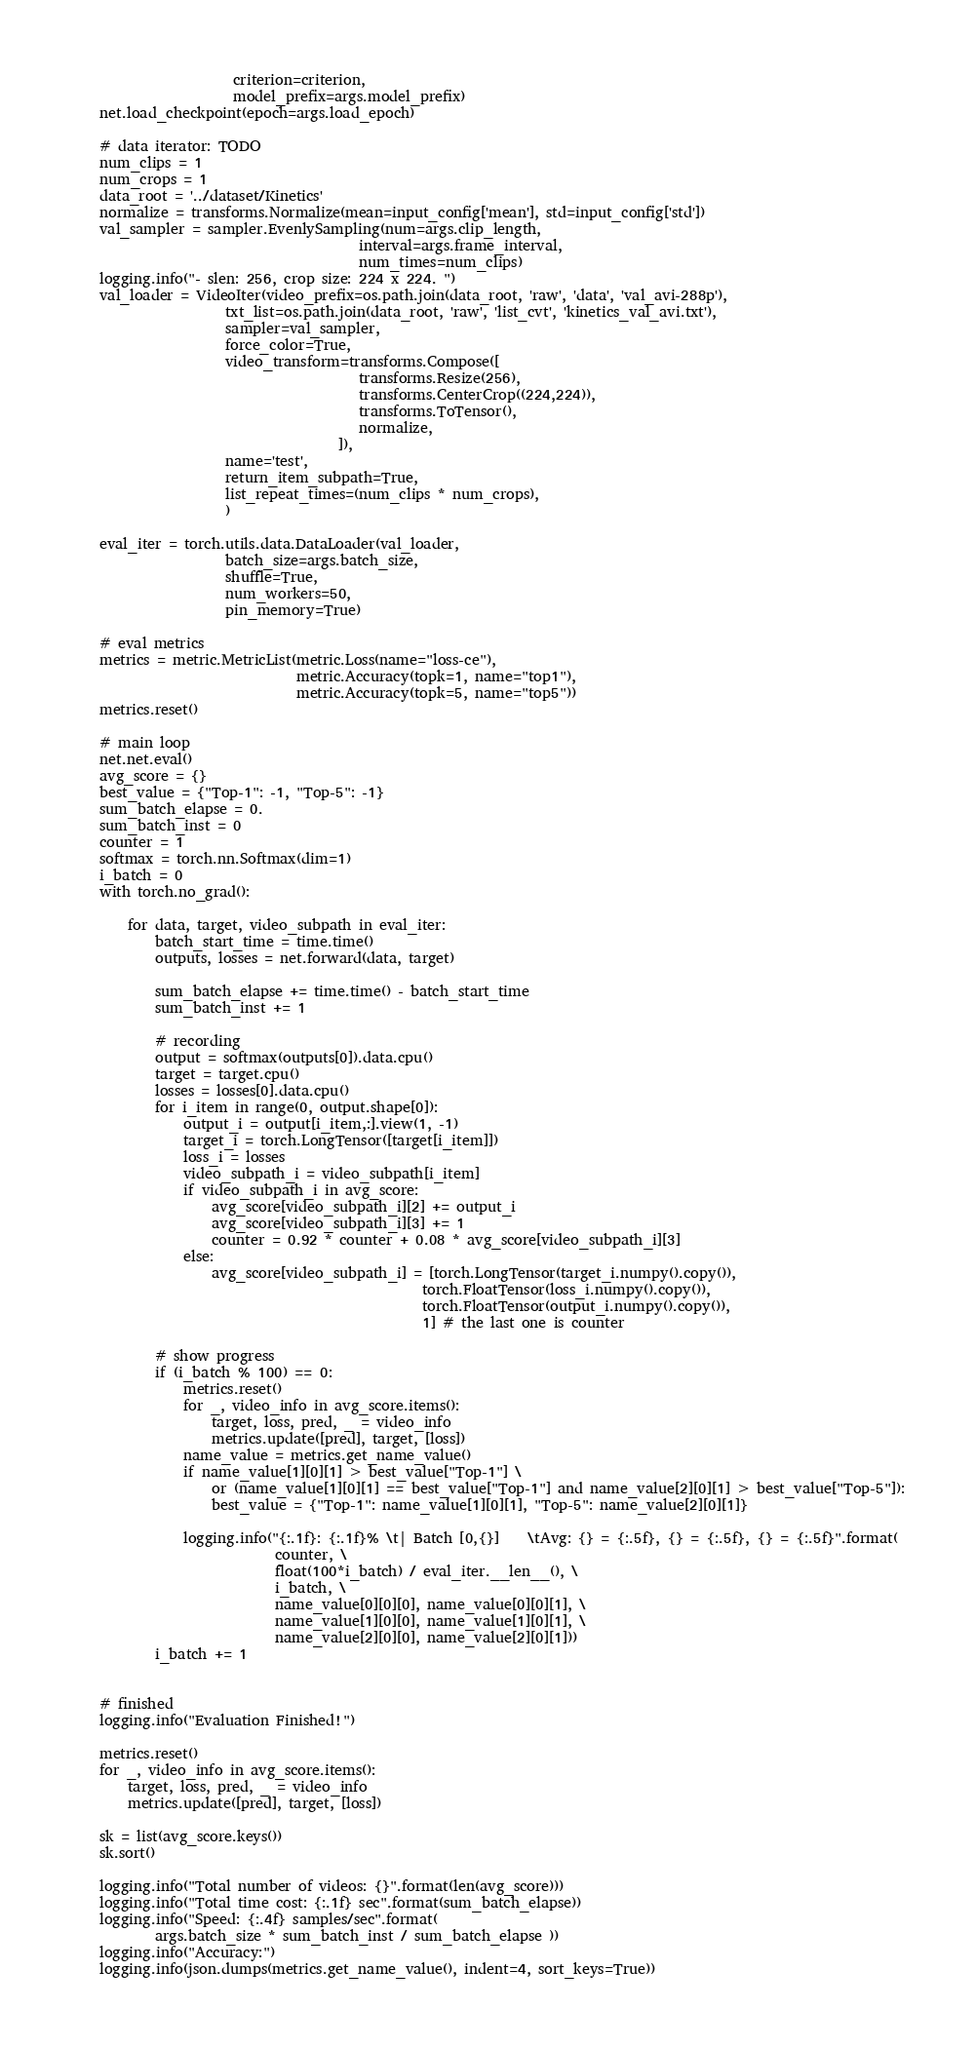Convert code to text. <code><loc_0><loc_0><loc_500><loc_500><_Python_>                       criterion=criterion,
                       model_prefix=args.model_prefix)
    net.load_checkpoint(epoch=args.load_epoch)

    # data iterator: TODO
    num_clips = 1
    num_crops = 1
    data_root = '../dataset/Kinetics'
    normalize = transforms.Normalize(mean=input_config['mean'], std=input_config['std'])
    val_sampler = sampler.EvenlySampling(num=args.clip_length,
                                         interval=args.frame_interval,
                                         num_times=num_clips)
    logging.info("- slen: 256, crop size: 224 x 224. ")
    val_loader = VideoIter(video_prefix=os.path.join(data_root, 'raw', 'data', 'val_avi-288p'),
                      txt_list=os.path.join(data_root, 'raw', 'list_cvt', 'kinetics_val_avi.txt'),
                      sampler=val_sampler,
                      force_color=True,
                      video_transform=transforms.Compose([
                                         transforms.Resize(256),
                                         transforms.CenterCrop((224,224)),
                                         transforms.ToTensor(),
                                         normalize,
                                      ]),
                      name='test',
                      return_item_subpath=True,
                      list_repeat_times=(num_clips * num_crops),
                      )

    eval_iter = torch.utils.data.DataLoader(val_loader,
                      batch_size=args.batch_size,
                      shuffle=True,
                      num_workers=50,
                      pin_memory=True)

    # eval metrics
    metrics = metric.MetricList(metric.Loss(name="loss-ce"),
                                metric.Accuracy(topk=1, name="top1"),
                                metric.Accuracy(topk=5, name="top5"))
    metrics.reset()

    # main loop
    net.net.eval()
    avg_score = {}
    best_value = {"Top-1": -1, "Top-5": -1}
    sum_batch_elapse = 0.
    sum_batch_inst = 0
    counter = 1
    softmax = torch.nn.Softmax(dim=1)
    i_batch = 0
    with torch.no_grad():

        for data, target, video_subpath in eval_iter:
            batch_start_time = time.time()
            outputs, losses = net.forward(data, target)

            sum_batch_elapse += time.time() - batch_start_time
            sum_batch_inst += 1

            # recording
            output = softmax(outputs[0]).data.cpu()
            target = target.cpu()
            losses = losses[0].data.cpu()
            for i_item in range(0, output.shape[0]):
                output_i = output[i_item,:].view(1, -1)
                target_i = torch.LongTensor([target[i_item]])
                loss_i = losses
                video_subpath_i = video_subpath[i_item]
                if video_subpath_i in avg_score:
                    avg_score[video_subpath_i][2] += output_i
                    avg_score[video_subpath_i][3] += 1
                    counter = 0.92 * counter + 0.08 * avg_score[video_subpath_i][3]
                else:
                    avg_score[video_subpath_i] = [torch.LongTensor(target_i.numpy().copy()),
                                                  torch.FloatTensor(loss_i.numpy().copy()),
                                                  torch.FloatTensor(output_i.numpy().copy()),
                                                  1] # the last one is counter

            # show progress
            if (i_batch % 100) == 0:
                metrics.reset()
                for _, video_info in avg_score.items():
                    target, loss, pred, _ = video_info
                    metrics.update([pred], target, [loss])
                name_value = metrics.get_name_value()
                if name_value[1][0][1] > best_value["Top-1"] \
                    or (name_value[1][0][1] == best_value["Top-1"] and name_value[2][0][1] > best_value["Top-5"]):
                    best_value = {"Top-1": name_value[1][0][1], "Top-5": name_value[2][0][1]}

                logging.info("{:.1f}: {:.1f}% \t| Batch [0,{}]    \tAvg: {} = {:.5f}, {} = {:.5f}, {} = {:.5f}".format(
                             counter, \
                             float(100*i_batch) / eval_iter.__len__(), \
                             i_batch, \
                             name_value[0][0][0], name_value[0][0][1], \
                             name_value[1][0][0], name_value[1][0][1], \
                             name_value[2][0][0], name_value[2][0][1]))
            i_batch += 1


    # finished
    logging.info("Evaluation Finished!")

    metrics.reset()
    for _, video_info in avg_score.items():
        target, loss, pred, _ = video_info
        metrics.update([pred], target, [loss])

    sk = list(avg_score.keys())
    sk.sort()

    logging.info("Total number of videos: {}".format(len(avg_score)))
    logging.info("Total time cost: {:.1f} sec".format(sum_batch_elapse))
    logging.info("Speed: {:.4f} samples/sec".format(
            args.batch_size * sum_batch_inst / sum_batch_elapse ))
    logging.info("Accuracy:")
    logging.info(json.dumps(metrics.get_name_value(), indent=4, sort_keys=True))

</code> 